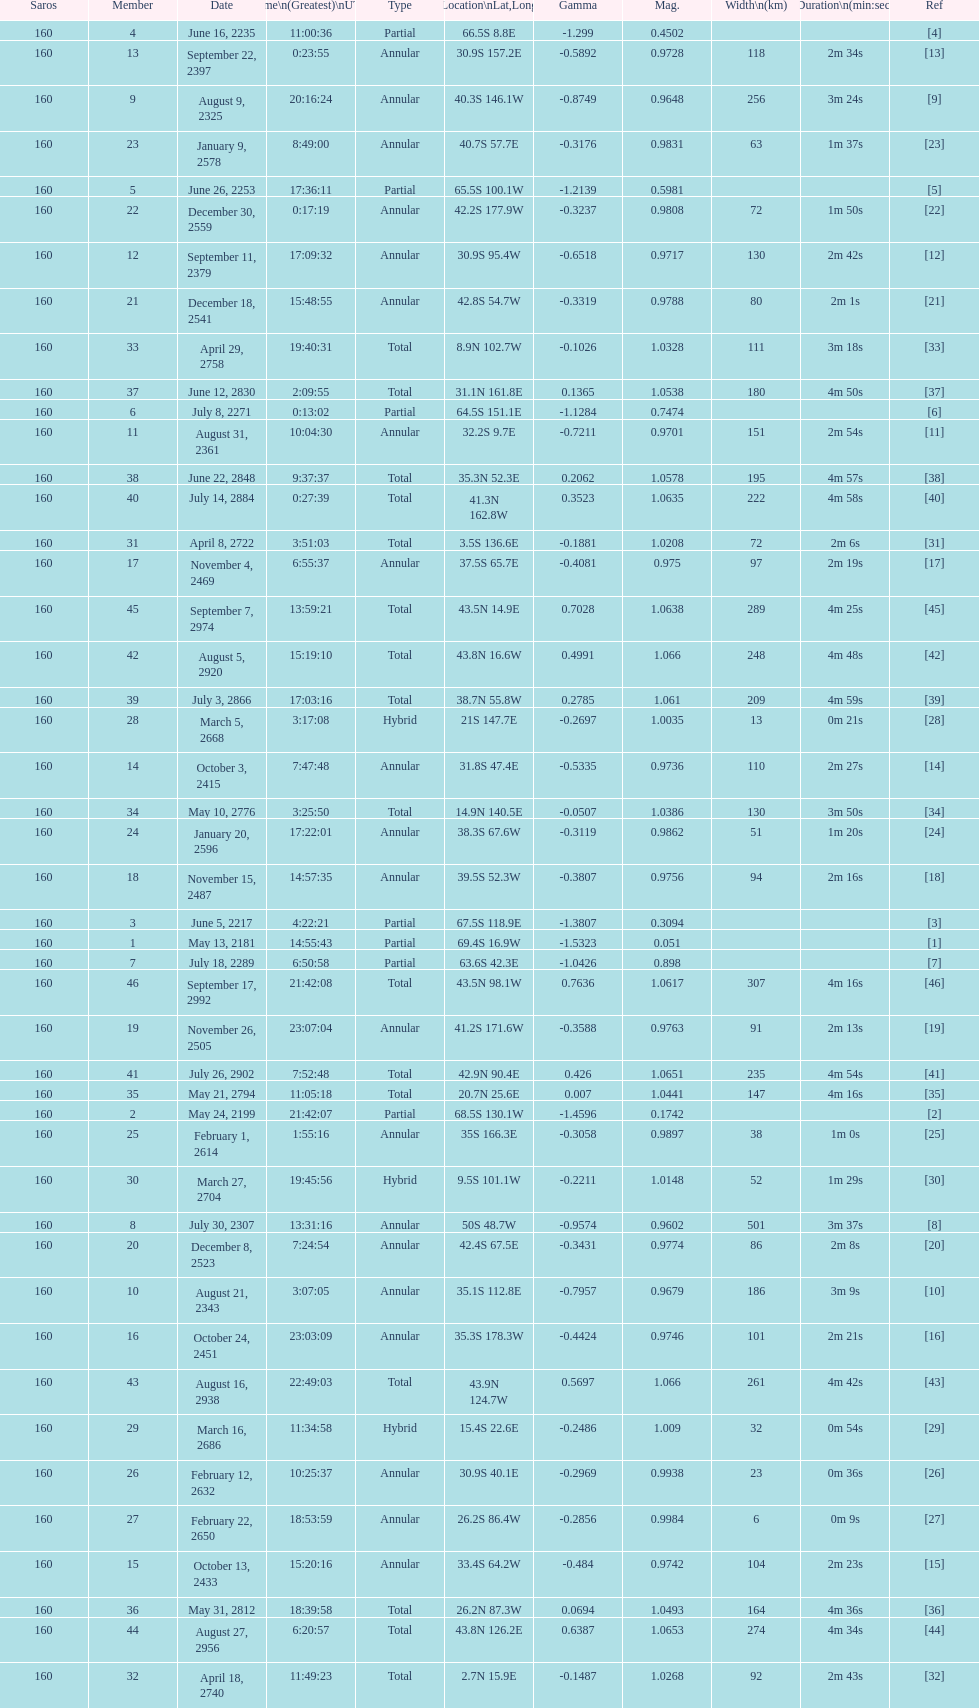When will the next solar saros be after the may 24, 2199 solar saros occurs? June 5, 2217. 